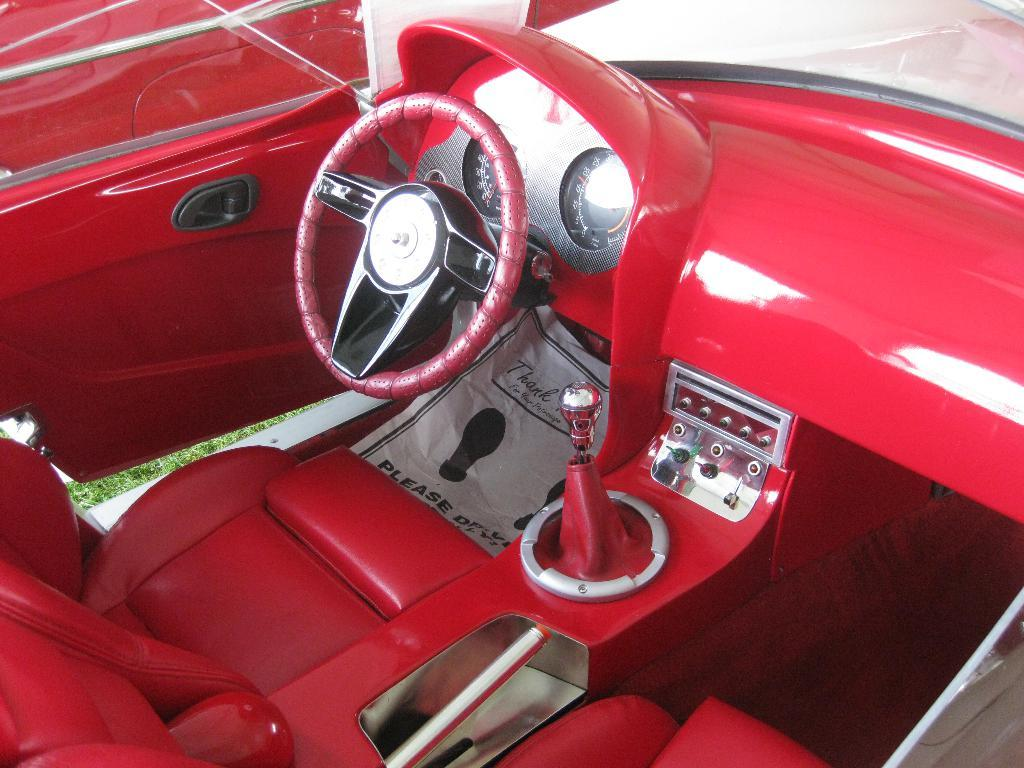What color is the car in the image? The car in the image is red. What is used for controlling the direction of the car? The car has a steering wheel for controlling its direction. How does the driver change gears in the car? The car has a gear rod for changing gears. What can be found inside the car for passengers to sit on? The car has seats for passengers to sit on. What type of vegetation is visible to the left of the car? There is grass visible to the left of the car. How does the driver enter the car? The car has a door on the left side for the driver to enter. What type of copper material is used to make the moon visible in the image? There is no moon or copper material present in the image; it features a red car with specific features and grass visible to the left. 